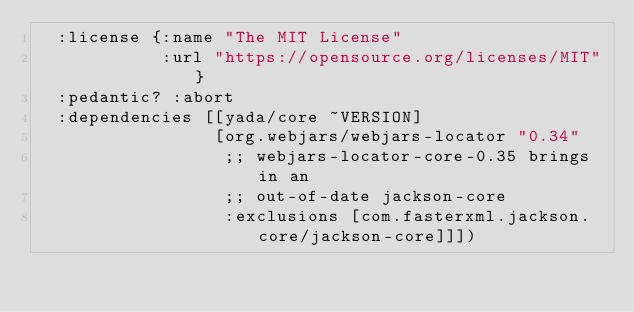Convert code to text. <code><loc_0><loc_0><loc_500><loc_500><_Clojure_>  :license {:name "The MIT License"
            :url "https://opensource.org/licenses/MIT"}
  :pedantic? :abort
  :dependencies [[yada/core ~VERSION]
                 [org.webjars/webjars-locator "0.34"
                  ;; webjars-locator-core-0.35 brings in an
                  ;; out-of-date jackson-core
                  :exclusions [com.fasterxml.jackson.core/jackson-core]]])
</code> 